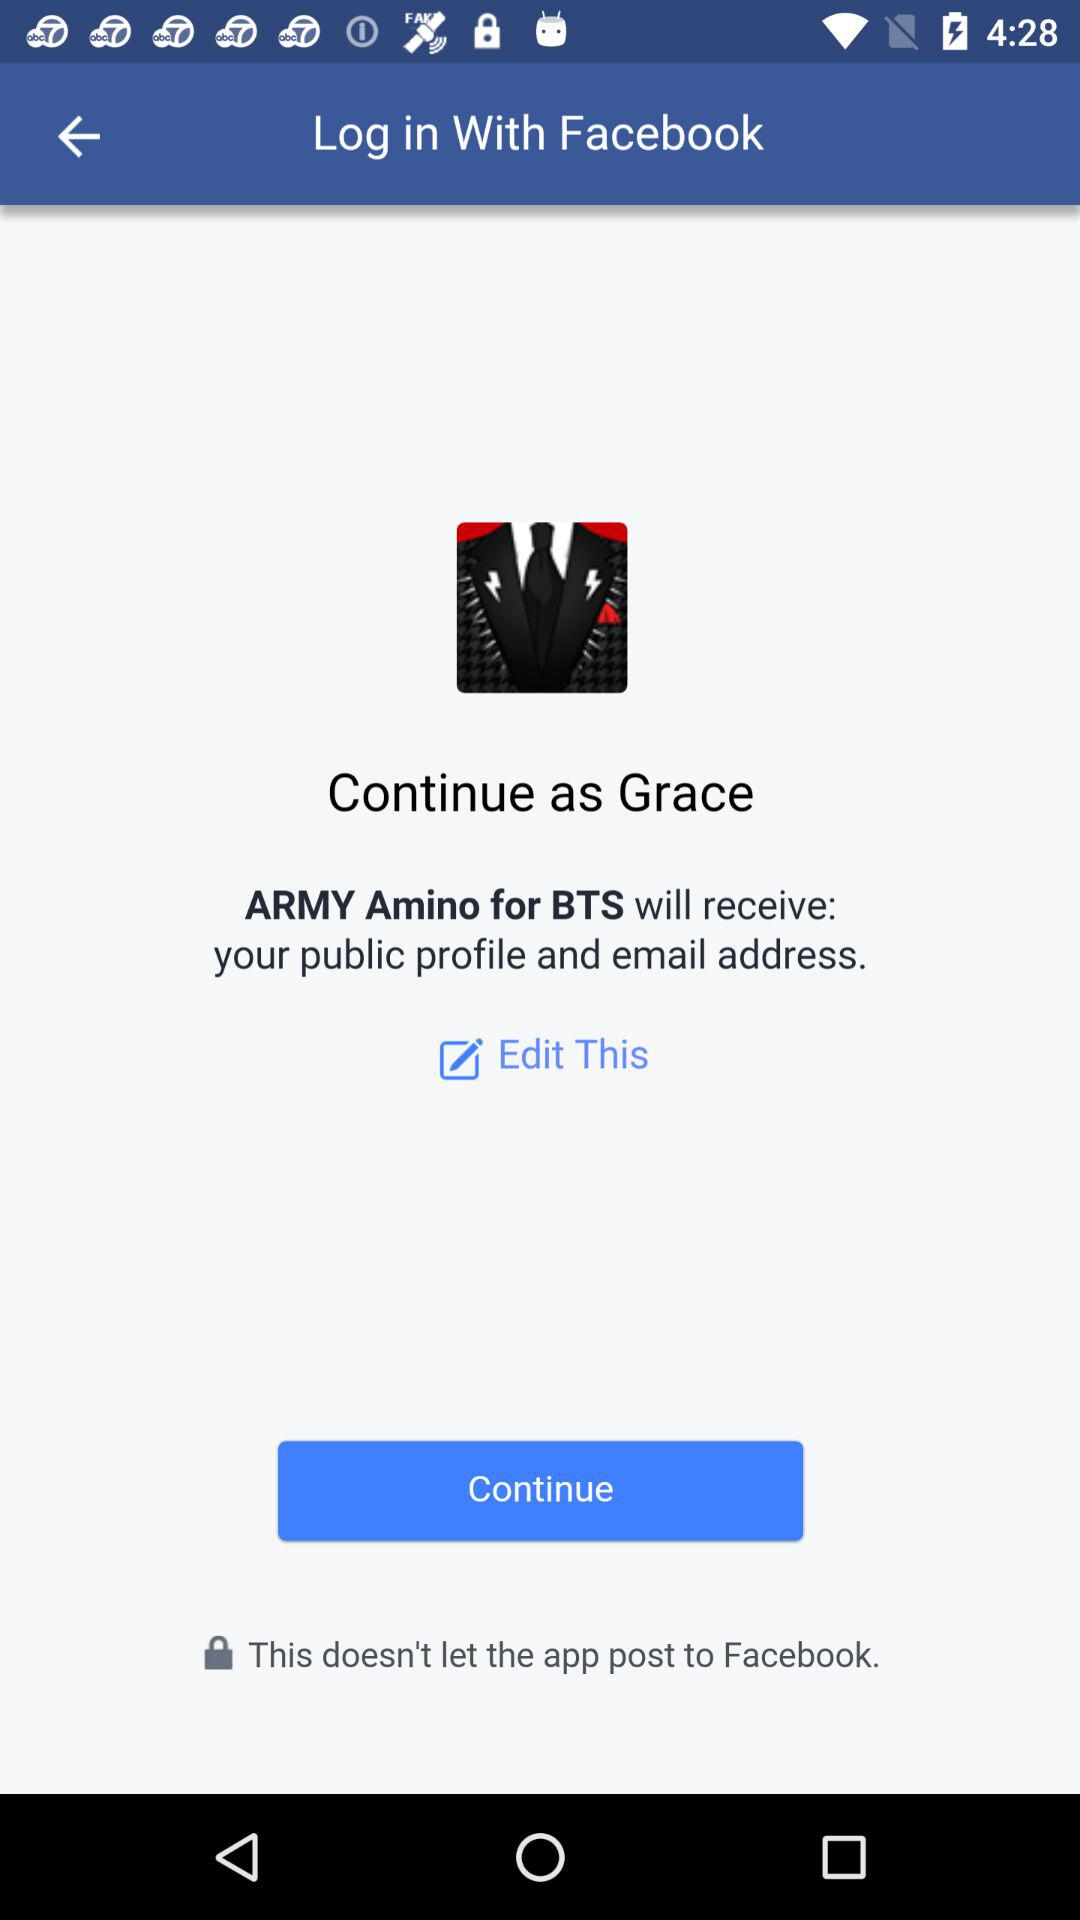Who will receive the public profile and email address? The application "ARMY Amino for BTS" will receive the public profile and email address. 